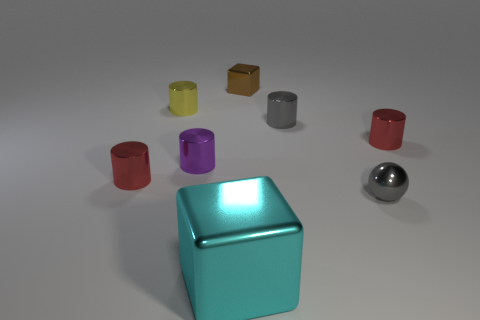What material is the cube in front of the red metal thing that is to the left of the small red object right of the yellow object made of?
Keep it short and to the point. Metal. What size is the purple object that is made of the same material as the yellow thing?
Your response must be concise. Small. Is there anything else that is the same color as the small metallic block?
Keep it short and to the point. No. Is the color of the cube on the right side of the big cyan metallic object the same as the shiny block that is in front of the yellow object?
Keep it short and to the point. No. What is the color of the small shiny cylinder in front of the purple metallic object?
Your response must be concise. Red. There is a red shiny object that is left of the yellow thing; does it have the same size as the large cyan object?
Offer a very short reply. No. Are there fewer small shiny spheres than green balls?
Your response must be concise. No. The thing that is the same color as the small metal sphere is what shape?
Offer a very short reply. Cylinder. There is a purple object; how many metallic cylinders are behind it?
Offer a very short reply. 3. Is the shape of the small purple thing the same as the tiny brown object?
Provide a succinct answer. No. 